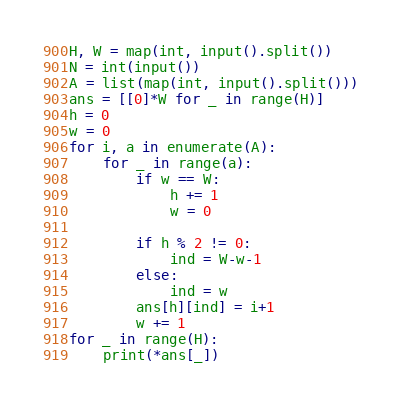Convert code to text. <code><loc_0><loc_0><loc_500><loc_500><_Python_>H, W = map(int, input().split())
N = int(input())
A = list(map(int, input().split()))
ans = [[0]*W for _ in range(H)]
h = 0
w = 0
for i, a in enumerate(A):
    for _ in range(a):
        if w == W:
            h += 1
            w = 0
        
        if h % 2 != 0:
            ind = W-w-1
        else:
            ind = w
        ans[h][ind] = i+1
        w += 1
for _ in range(H):
    print(*ans[_])
</code> 